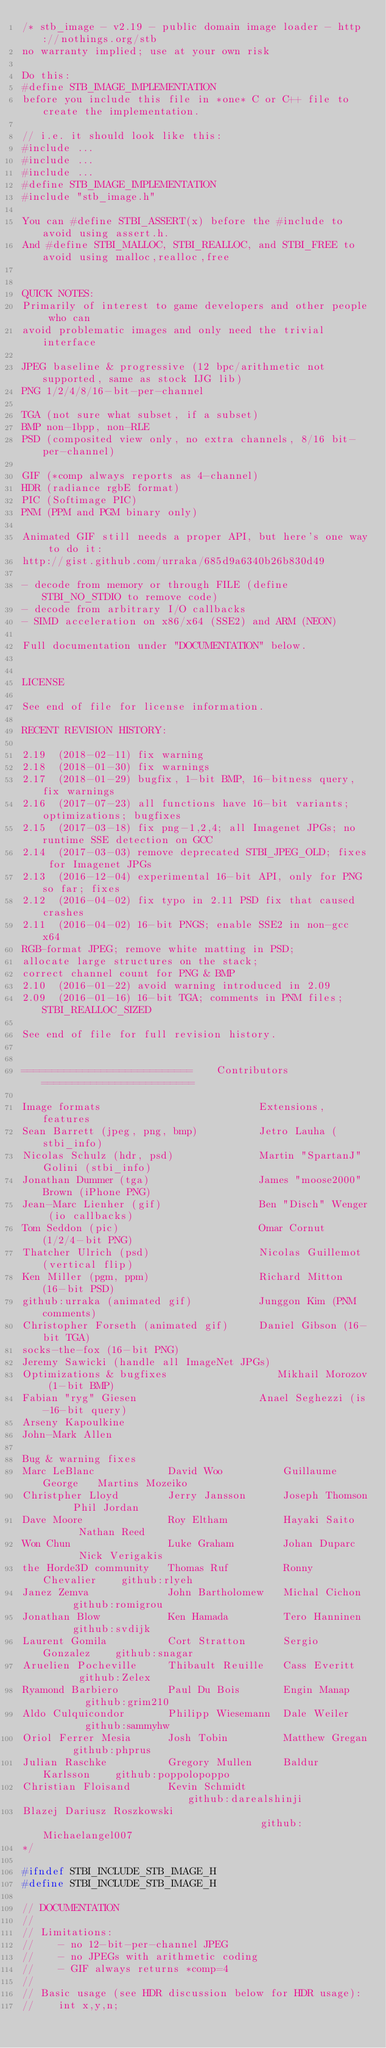<code> <loc_0><loc_0><loc_500><loc_500><_C_>/* stb_image - v2.19 - public domain image loader - http://nothings.org/stb
no warranty implied; use at your own risk

Do this:
#define STB_IMAGE_IMPLEMENTATION
before you include this file in *one* C or C++ file to create the implementation.

// i.e. it should look like this:
#include ...
#include ...
#include ...
#define STB_IMAGE_IMPLEMENTATION
#include "stb_image.h"

You can #define STBI_ASSERT(x) before the #include to avoid using assert.h.
And #define STBI_MALLOC, STBI_REALLOC, and STBI_FREE to avoid using malloc,realloc,free


QUICK NOTES:
Primarily of interest to game developers and other people who can
avoid problematic images and only need the trivial interface

JPEG baseline & progressive (12 bpc/arithmetic not supported, same as stock IJG lib)
PNG 1/2/4/8/16-bit-per-channel

TGA (not sure what subset, if a subset)
BMP non-1bpp, non-RLE
PSD (composited view only, no extra channels, 8/16 bit-per-channel)

GIF (*comp always reports as 4-channel)
HDR (radiance rgbE format)
PIC (Softimage PIC)
PNM (PPM and PGM binary only)

Animated GIF still needs a proper API, but here's one way to do it:
http://gist.github.com/urraka/685d9a6340b26b830d49

- decode from memory or through FILE (define STBI_NO_STDIO to remove code)
- decode from arbitrary I/O callbacks
- SIMD acceleration on x86/x64 (SSE2) and ARM (NEON)

Full documentation under "DOCUMENTATION" below.


LICENSE

See end of file for license information.

RECENT REVISION HISTORY:

2.19  (2018-02-11) fix warning
2.18  (2018-01-30) fix warnings
2.17  (2018-01-29) bugfix, 1-bit BMP, 16-bitness query, fix warnings
2.16  (2017-07-23) all functions have 16-bit variants; optimizations; bugfixes
2.15  (2017-03-18) fix png-1,2,4; all Imagenet JPGs; no runtime SSE detection on GCC
2.14  (2017-03-03) remove deprecated STBI_JPEG_OLD; fixes for Imagenet JPGs
2.13  (2016-12-04) experimental 16-bit API, only for PNG so far; fixes
2.12  (2016-04-02) fix typo in 2.11 PSD fix that caused crashes
2.11  (2016-04-02) 16-bit PNGS; enable SSE2 in non-gcc x64
RGB-format JPEG; remove white matting in PSD;
allocate large structures on the stack;
correct channel count for PNG & BMP
2.10  (2016-01-22) avoid warning introduced in 2.09
2.09  (2016-01-16) 16-bit TGA; comments in PNM files; STBI_REALLOC_SIZED

See end of file for full revision history.


============================    Contributors    =========================

Image formats                          Extensions, features
Sean Barrett (jpeg, png, bmp)          Jetro Lauha (stbi_info)
Nicolas Schulz (hdr, psd)              Martin "SpartanJ" Golini (stbi_info)
Jonathan Dummer (tga)                  James "moose2000" Brown (iPhone PNG)
Jean-Marc Lienher (gif)                Ben "Disch" Wenger (io callbacks)
Tom Seddon (pic)                       Omar Cornut (1/2/4-bit PNG)
Thatcher Ulrich (psd)                  Nicolas Guillemot (vertical flip)
Ken Miller (pgm, ppm)                  Richard Mitton (16-bit PSD)
github:urraka (animated gif)           Junggon Kim (PNM comments)
Christopher Forseth (animated gif)     Daniel Gibson (16-bit TGA)
socks-the-fox (16-bit PNG)
Jeremy Sawicki (handle all ImageNet JPGs)
Optimizations & bugfixes                  Mikhail Morozov (1-bit BMP)
Fabian "ryg" Giesen                    Anael Seghezzi (is-16-bit query)
Arseny Kapoulkine
John-Mark Allen

Bug & warning fixes
Marc LeBlanc            David Woo          Guillaume George   Martins Mozeiko
Christpher Lloyd        Jerry Jansson      Joseph Thomson     Phil Jordan
Dave Moore              Roy Eltham         Hayaki Saito       Nathan Reed
Won Chun                Luke Graham        Johan Duparc       Nick Verigakis
the Horde3D community   Thomas Ruf         Ronny Chevalier    github:rlyeh
Janez Zemva             John Bartholomew   Michal Cichon      github:romigrou
Jonathan Blow           Ken Hamada         Tero Hanninen      github:svdijk
Laurent Gomila          Cort Stratton      Sergio Gonzalez    github:snagar
Aruelien Pocheville     Thibault Reuille   Cass Everitt       github:Zelex
Ryamond Barbiero        Paul Du Bois       Engin Manap        github:grim210
Aldo Culquicondor       Philipp Wiesemann  Dale Weiler        github:sammyhw
Oriol Ferrer Mesia      Josh Tobin         Matthew Gregan     github:phprus
Julian Raschke          Gregory Mullen     Baldur Karlsson    github:poppolopoppo
Christian Floisand      Kevin Schmidt                         github:darealshinji
Blazej Dariusz Roszkowski                                     github:Michaelangel007
*/

#ifndef STBI_INCLUDE_STB_IMAGE_H
#define STBI_INCLUDE_STB_IMAGE_H

// DOCUMENTATION
//
// Limitations:
//    - no 12-bit-per-channel JPEG
//    - no JPEGs with arithmetic coding
//    - GIF always returns *comp=4
//
// Basic usage (see HDR discussion below for HDR usage):
//    int x,y,n;</code> 